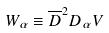<formula> <loc_0><loc_0><loc_500><loc_500>W _ { \alpha } \equiv \overline { D } ^ { 2 } D _ { \alpha } V</formula> 